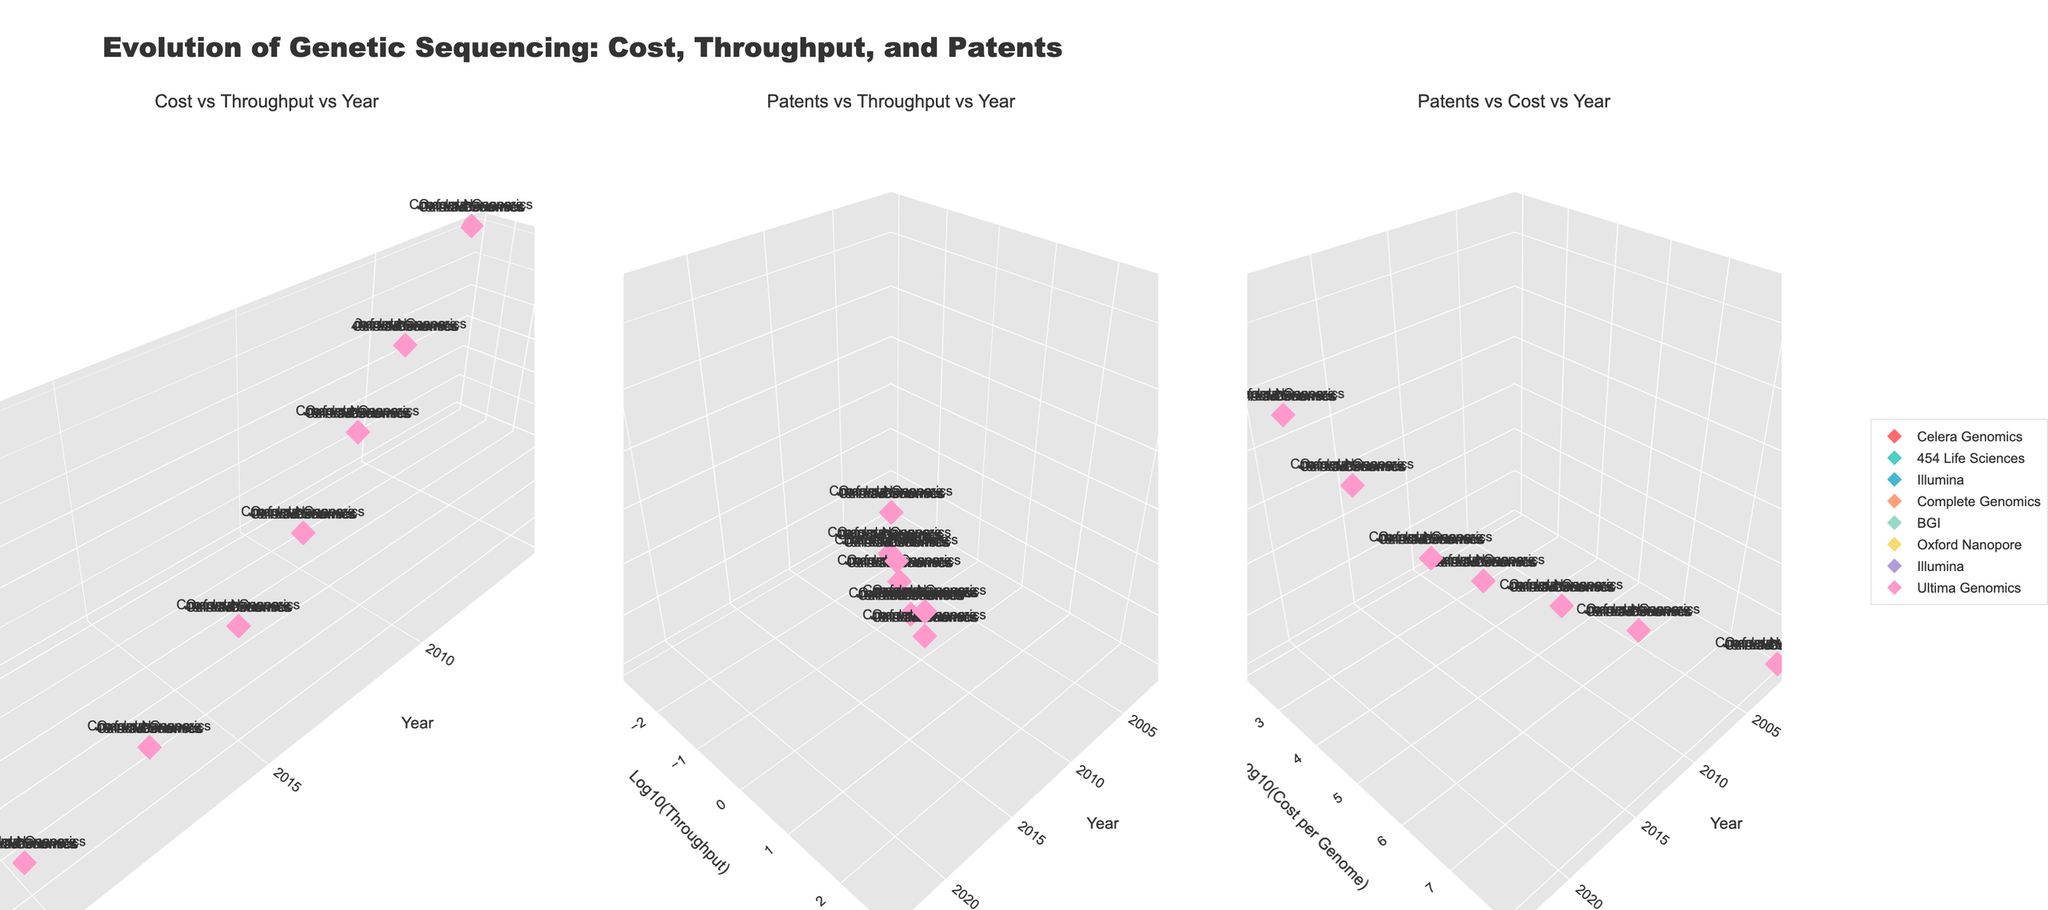What's the general trend in the cost per genome over the years? The plot "Cost vs Throughput vs Year" shows that the cost per genome has decreased logarithmically over the years. Companies like Celera Genomics in 2001 had costs of $100,000,000 per genome, which has significantly reduced to $100 by Ultima Genomics in 2023.
Answer: Decreasing Which company has the highest patent filings? In the "Patents vs Throughput vs Year" plot, Ultima Genomics in 2023 has the highest patent filings, with a total of 650 patents filed.
Answer: Ultima Genomics How has throughput improved from 2001 to 2023? The "Cost vs Throughput vs Year" subplot shows that throughput in genomes per day has increased logarithmically from Celera Genomics in 2001 with 0.001 genomes per day to Ultima Genomics in 2023 with 500 genomes per day.
Answer: Increased What is the relationship between throughput and the number of patents filed? In the "Patents vs Throughput vs Year" subplot, an increase in throughput is generally associated with an increase in the number of patents filed.
Answer: Positive relationship Which company had the largest drop in cost per genome relative to its throughput? By examining the "Cost vs Throughput vs Year" plot, the largest drop is observed with Complete Genomics from 2011. Their cost dropped to $10,000 with a throughput of 1 genome per day.
Answer: Complete Genomics How do the throughput values change in relation to years on a log scale? In both "Cost vs Throughput vs Year" and "Patents vs Throughput vs Year" subplots, throughput improves exponentially as we move from left to right, indicating a consistent increase in genome sequencing capabilities.
Answer: Exponential increase Between 2011 and 2014, which company had a more significant improvement in throughput, and by how much? Complete Genomics in 2011 had a throughput of 1 genome per day, whereas BGI in 2014 had a throughput of 10 genomes per day. The improvement is by 9 genomes per day.
Answer: BGI, by 9 genomes per day What is the most significant factor influencing the number of patents filed, the cost per genome or the throughput? Based on "Patents vs Throughput vs Year" and "Patents vs Cost vs Year" plots, it appears throughput has a more direct and stronger influence on the number of patents filed compared to cost.
Answer: Throughput What year did Illumina first appear with a significant patent filing number, and how many were filed? In the "Patents vs Throughput vs Year" plot, Illumina first appears in 2008 with a significant number of 75 patents filed.
Answer: 2008, 75 patents 